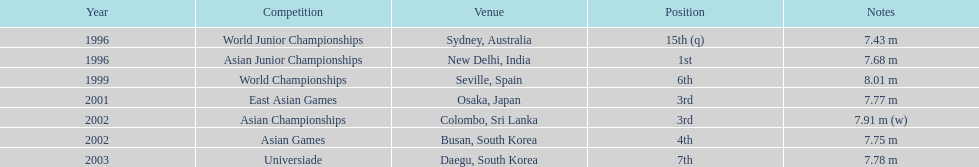What is the quantity of contests that have been participated in? 7. 